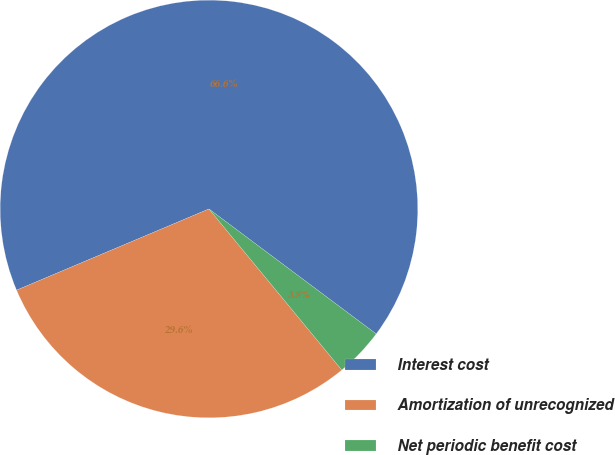Convert chart to OTSL. <chart><loc_0><loc_0><loc_500><loc_500><pie_chart><fcel>Interest cost<fcel>Amortization of unrecognized<fcel>Net periodic benefit cost<nl><fcel>66.57%<fcel>29.62%<fcel>3.81%<nl></chart> 